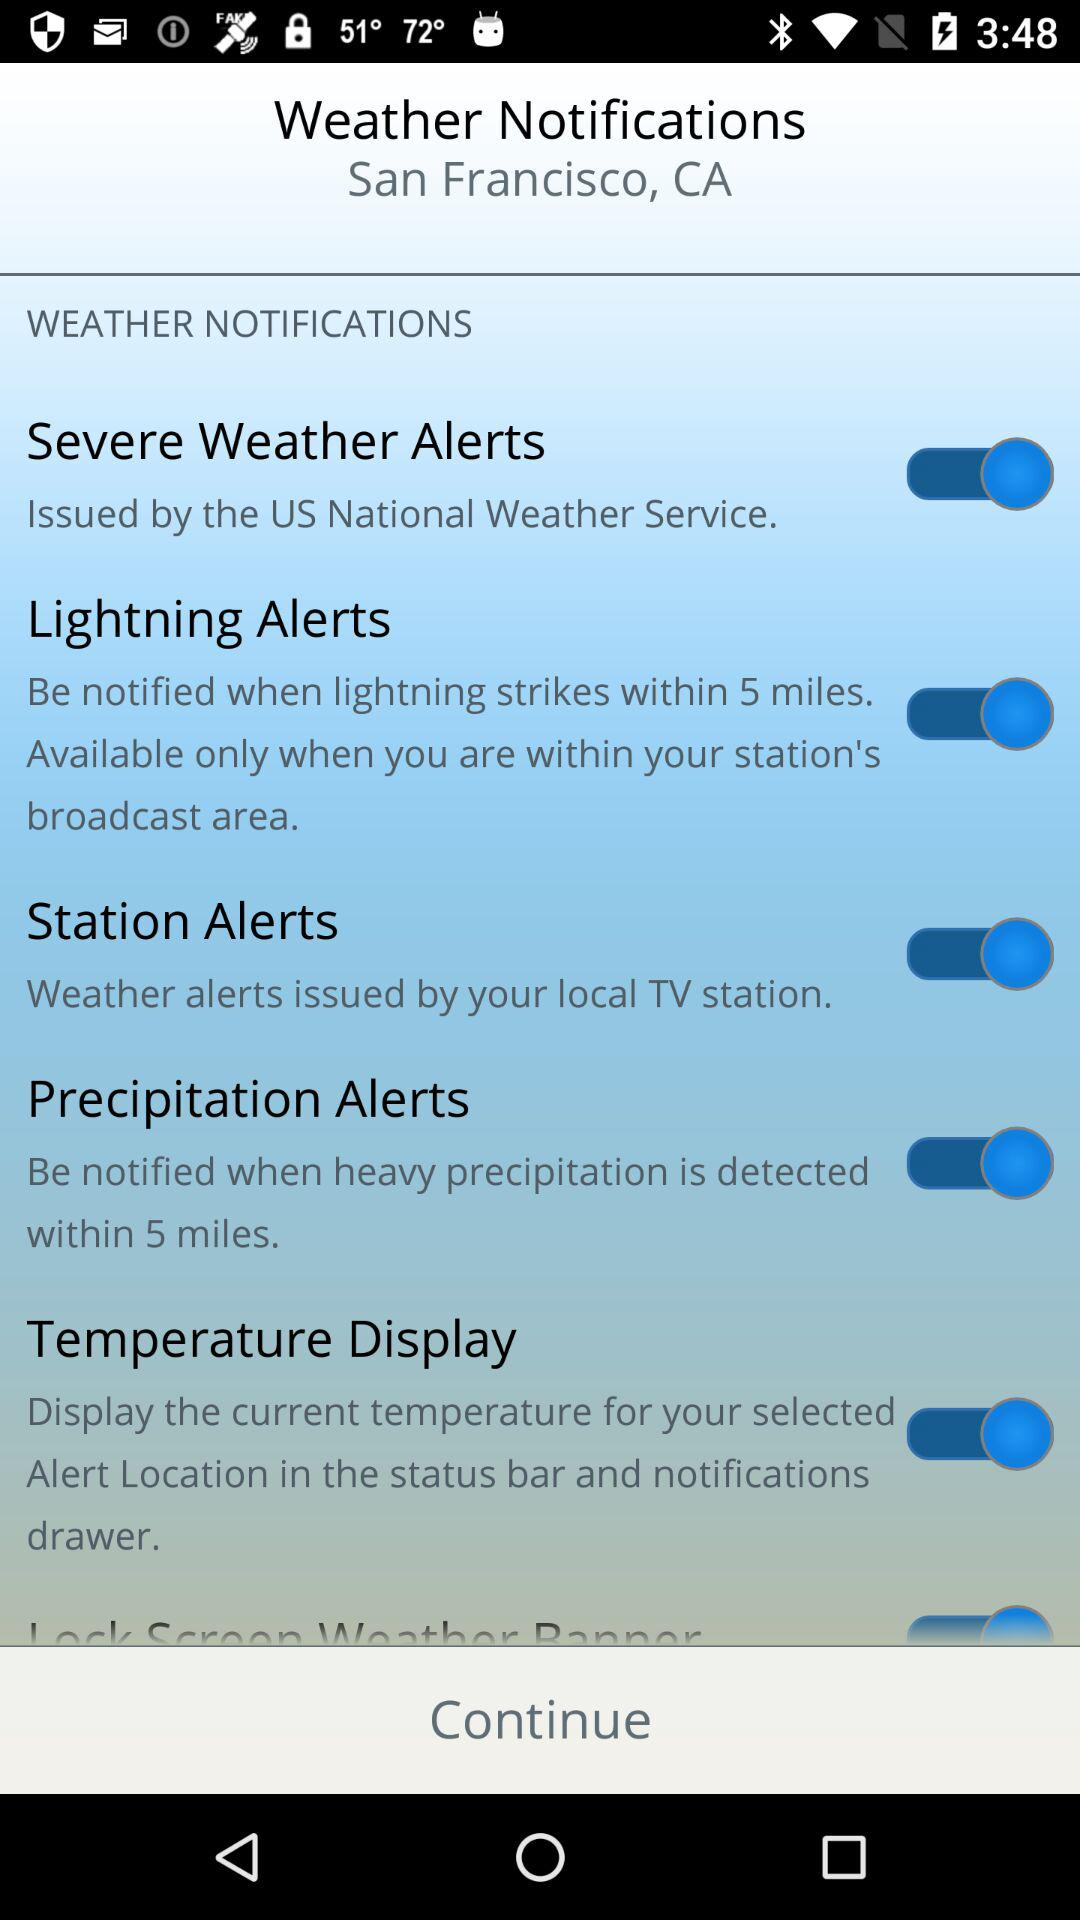What is the status of the "Lightning Alerts"? The status of the "Lightning Alerts" is "on". 